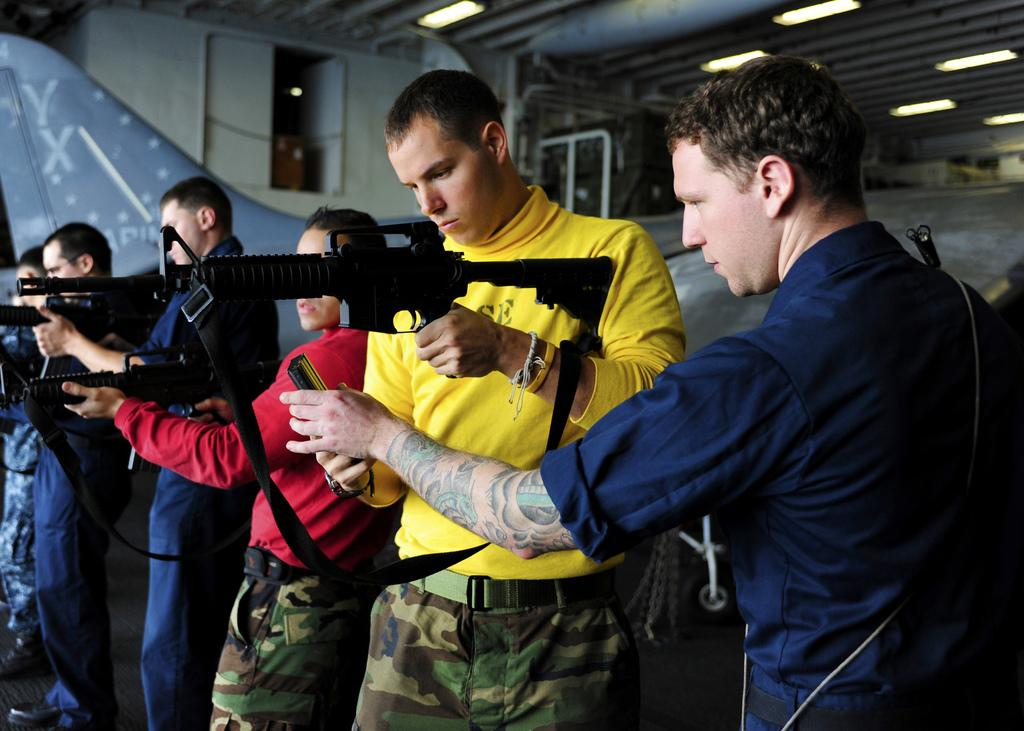What are the people in the image doing? The people in the image are holding guns. What can be seen in the background of the image? There is a wall, an airplane wing, and lights in the background of the image. What type of bubble is floating near the people in the image? There is no bubble present in the image. What flag can be seen in the image? There is no flag present in the image. 